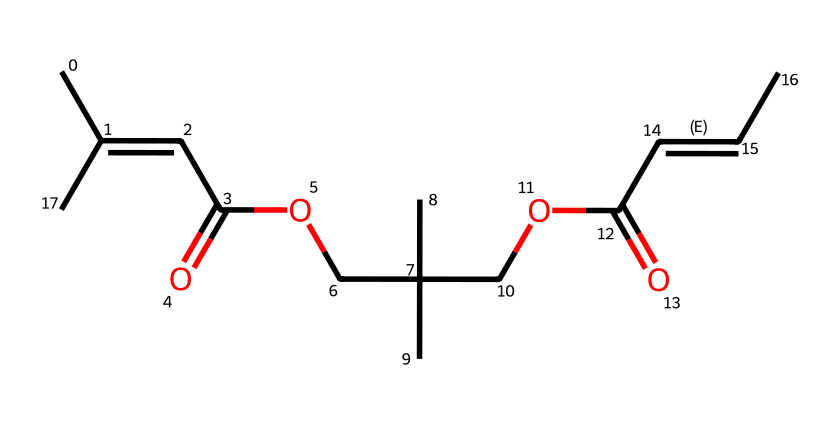what is the main functional group present in the chemical? The chemical structure has a carboxylic acid functional group, denoted by the presence of a -COOH group attached to a carbon.
Answer: carboxylic acid how many carbon atoms are in the chemical? By analyzing the structure from the SMILES representation, we can count a total of 14 carbon atoms present in the entire molecule.
Answer: 14 what is the degree of unsaturation in this chemical? The presence of double bonds and possibly a ring in the structure contributes to the degree of unsaturation. In this case, we have 4 double bonds, indicating a degree of unsaturation of 4.
Answer: 4 in which configuration does the chain of carbons around the double bonds exist? The molecule has geometric isomers due to the double bonds in the carbon chains, indicating E-Z configurations. The specific positioning of substituents around the double bonds derives that information.
Answer: E-Z configurations how many ester groups are present in this chemical? By examining the SMILES, we can identify two ester groups (-COO-) within the structure, showing that there are two ester linkages present.
Answer: 2 what type of geometric isomers are possible for this chemical? Given the configuration of the double bonds in the carbon chains and substitution patterns, this molecule can exist as E (trans) and Z (cis) geometric isomers.
Answer: E and Z what physical property of this chemical is likely affected by the presence of geometric isomers? The different spatial arrangements of atoms in the E and Z isomers can lead to variations in physical properties such as boiling point, solubility, and reactivity.
Answer: boiling point, solubility, reactivity 